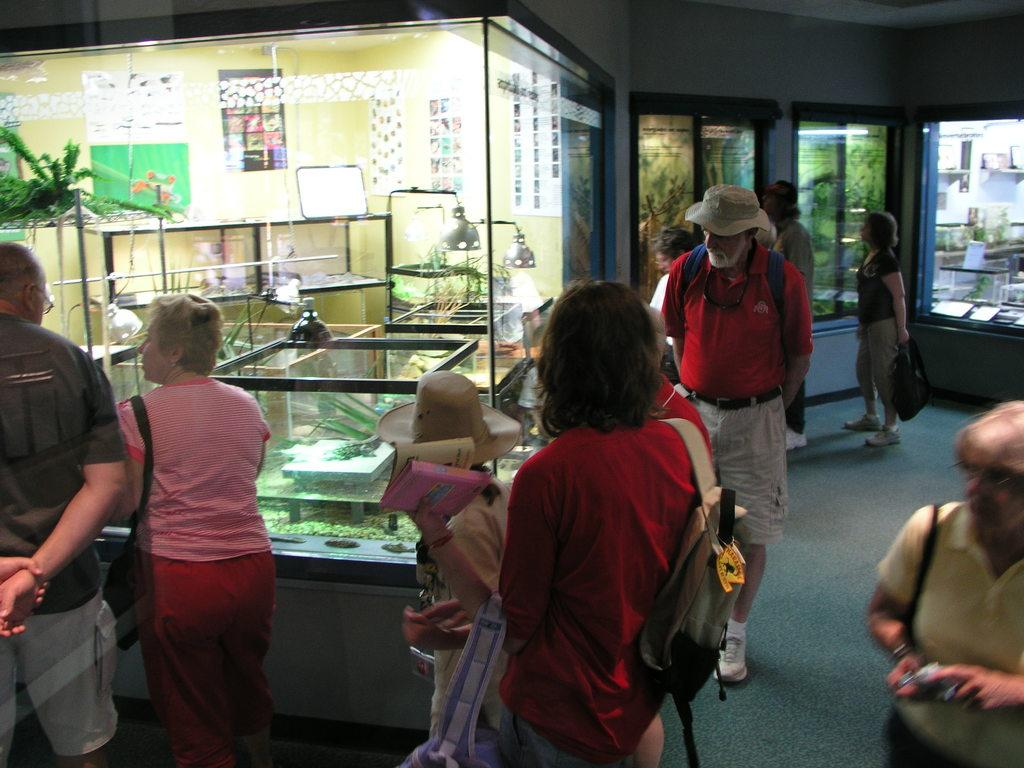Who is standing on the left side of the image? There is a man standing on the left side of the image. Who is standing beside the man? There is a woman standing beside the man. What can be seen in the image besides the man and woman? There is a glass in the image. Are there any other people in the image? Yes, there are people observing the scene. What color is the ink on the man's tail in the image? There is no ink or tail present on the man in the image. 